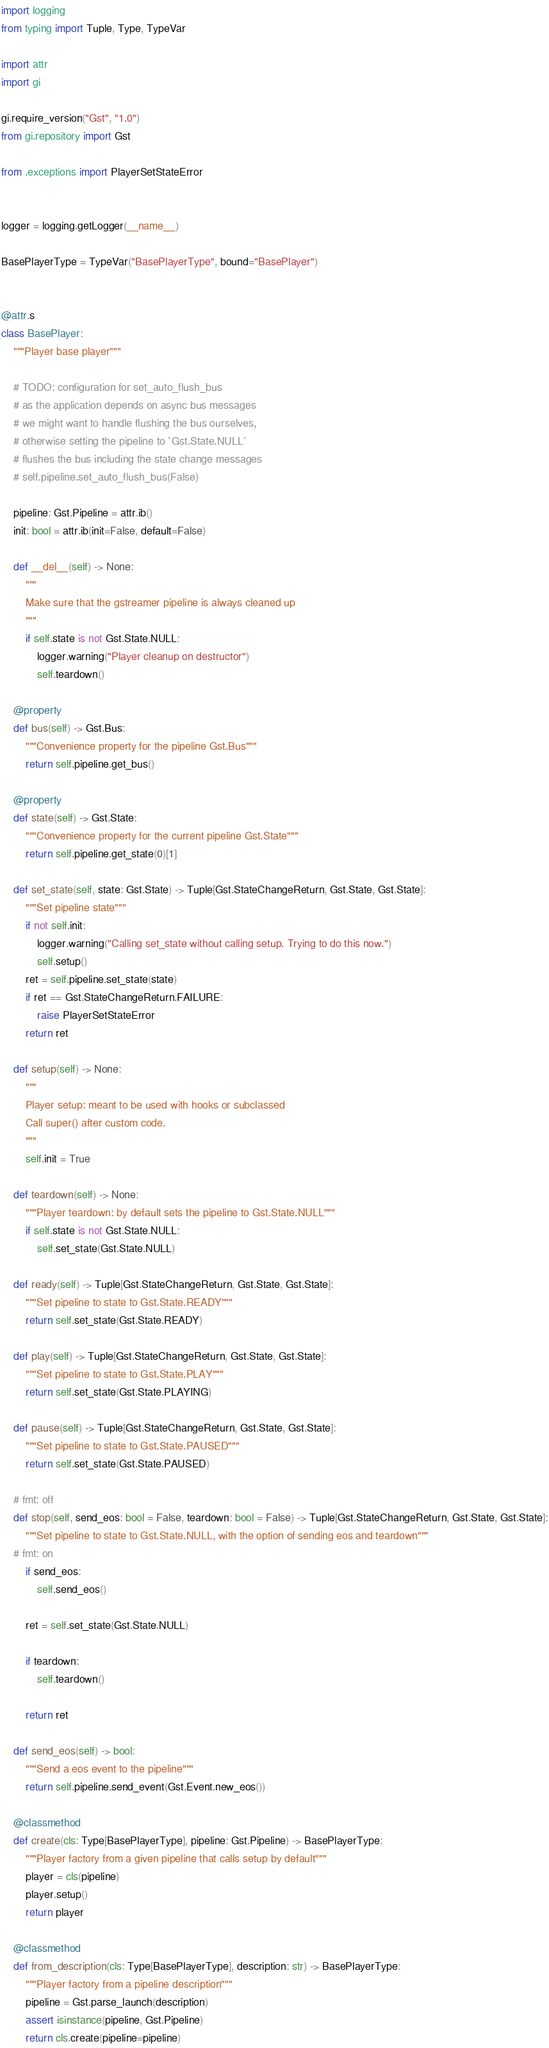Convert code to text. <code><loc_0><loc_0><loc_500><loc_500><_Python_>import logging
from typing import Tuple, Type, TypeVar

import attr
import gi

gi.require_version("Gst", "1.0")
from gi.repository import Gst

from .exceptions import PlayerSetStateError


logger = logging.getLogger(__name__)

BasePlayerType = TypeVar("BasePlayerType", bound="BasePlayer")


@attr.s
class BasePlayer:
    """Player base player"""

    # TODO: configuration for set_auto_flush_bus
    # as the application depends on async bus messages
    # we might want to handle flushing the bus ourselves,
    # otherwise setting the pipeline to `Gst.State.NULL`
    # flushes the bus including the state change messages
    # self.pipeline.set_auto_flush_bus(False)

    pipeline: Gst.Pipeline = attr.ib()
    init: bool = attr.ib(init=False, default=False)

    def __del__(self) -> None:
        """
        Make sure that the gstreamer pipeline is always cleaned up
        """
        if self.state is not Gst.State.NULL:
            logger.warning("Player cleanup on destructor")
            self.teardown()

    @property
    def bus(self) -> Gst.Bus:
        """Convenience property for the pipeline Gst.Bus"""
        return self.pipeline.get_bus()

    @property
    def state(self) -> Gst.State:
        """Convenience property for the current pipeline Gst.State"""
        return self.pipeline.get_state(0)[1]

    def set_state(self, state: Gst.State) -> Tuple[Gst.StateChangeReturn, Gst.State, Gst.State]:
        """Set pipeline state"""
        if not self.init:
            logger.warning("Calling set_state without calling setup. Trying to do this now.")
            self.setup()
        ret = self.pipeline.set_state(state)
        if ret == Gst.StateChangeReturn.FAILURE:
            raise PlayerSetStateError
        return ret

    def setup(self) -> None:
        """
        Player setup: meant to be used with hooks or subclassed
        Call super() after custom code.
        """
        self.init = True

    def teardown(self) -> None:
        """Player teardown: by default sets the pipeline to Gst.State.NULL"""
        if self.state is not Gst.State.NULL:
            self.set_state(Gst.State.NULL)

    def ready(self) -> Tuple[Gst.StateChangeReturn, Gst.State, Gst.State]:
        """Set pipeline to state to Gst.State.READY"""
        return self.set_state(Gst.State.READY)

    def play(self) -> Tuple[Gst.StateChangeReturn, Gst.State, Gst.State]:
        """Set pipeline to state to Gst.State.PLAY"""
        return self.set_state(Gst.State.PLAYING)

    def pause(self) -> Tuple[Gst.StateChangeReturn, Gst.State, Gst.State]:
        """Set pipeline to state to Gst.State.PAUSED"""
        return self.set_state(Gst.State.PAUSED)

    # fmt: off
    def stop(self, send_eos: bool = False, teardown: bool = False) -> Tuple[Gst.StateChangeReturn, Gst.State, Gst.State]:
        """Set pipeline to state to Gst.State.NULL, with the option of sending eos and teardown"""
    # fmt: on
        if send_eos:
            self.send_eos()

        ret = self.set_state(Gst.State.NULL)

        if teardown:
            self.teardown()

        return ret

    def send_eos(self) -> bool:
        """Send a eos event to the pipeline"""
        return self.pipeline.send_event(Gst.Event.new_eos())

    @classmethod
    def create(cls: Type[BasePlayerType], pipeline: Gst.Pipeline) -> BasePlayerType:
        """Player factory from a given pipeline that calls setup by default"""
        player = cls(pipeline)
        player.setup()
        return player

    @classmethod
    def from_description(cls: Type[BasePlayerType], description: str) -> BasePlayerType:
        """Player factory from a pipeline description"""
        pipeline = Gst.parse_launch(description)
        assert isinstance(pipeline, Gst.Pipeline)
        return cls.create(pipeline=pipeline)
</code> 